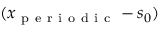Convert formula to latex. <formula><loc_0><loc_0><loc_500><loc_500>( x _ { p e r i o d i c } - s _ { 0 } )</formula> 